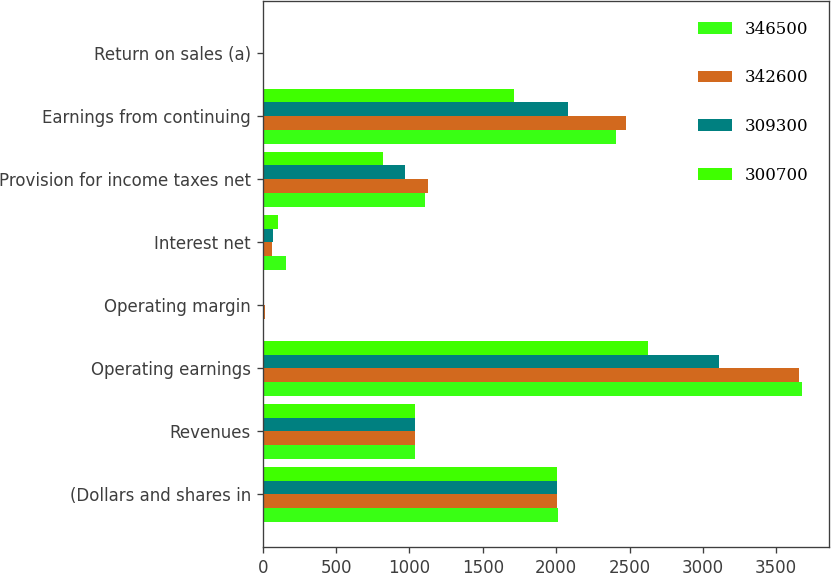Convert chart. <chart><loc_0><loc_0><loc_500><loc_500><stacked_bar_chart><ecel><fcel>(Dollars and shares in<fcel>Revenues<fcel>Operating earnings<fcel>Operating margin<fcel>Interest net<fcel>Provision for income taxes net<fcel>Earnings from continuing<fcel>Return on sales (a)<nl><fcel>346500<fcel>2009<fcel>1036.5<fcel>3675<fcel>11.5<fcel>160<fcel>1106<fcel>2407<fcel>7.5<nl><fcel>342600<fcel>2008<fcel>1036.5<fcel>3653<fcel>12.5<fcel>66<fcel>1126<fcel>2478<fcel>8.5<nl><fcel>309300<fcel>2007<fcel>1036.5<fcel>3113<fcel>11.4<fcel>70<fcel>967<fcel>2080<fcel>7.6<nl><fcel>300700<fcel>2006<fcel>1036.5<fcel>2625<fcel>10.9<fcel>101<fcel>817<fcel>1710<fcel>7.1<nl></chart> 